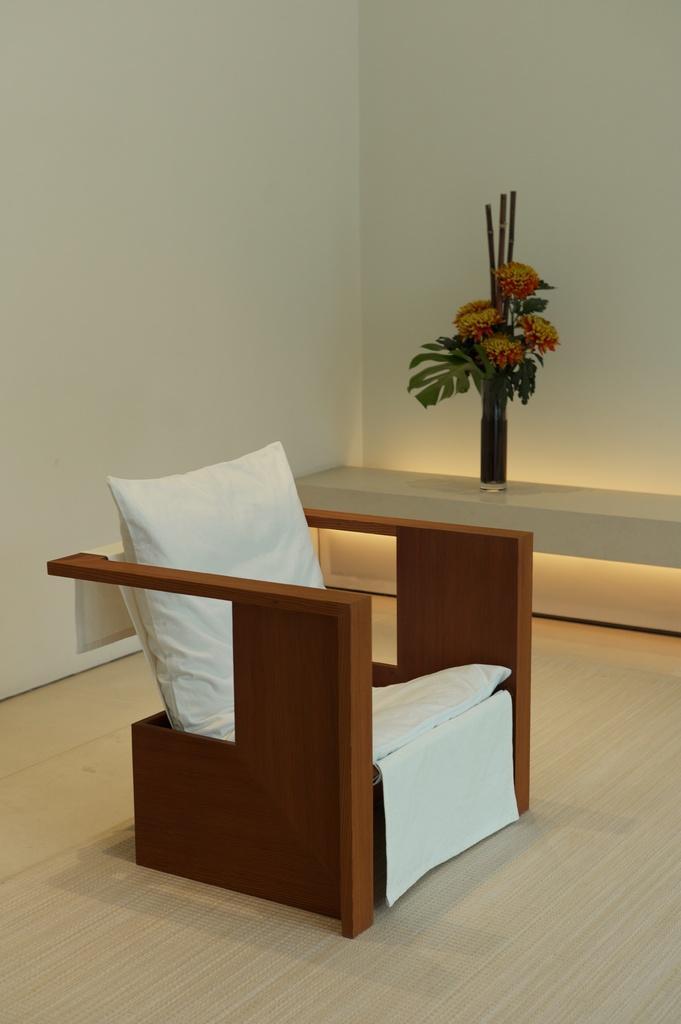Describe this image in one or two sentences. The image is inside the room. In the image there is a couch, on couch we can see pillows and a cloth. On right side of the image we can see flower pot with some flowers and plants in background there is a plant which is in white color. 